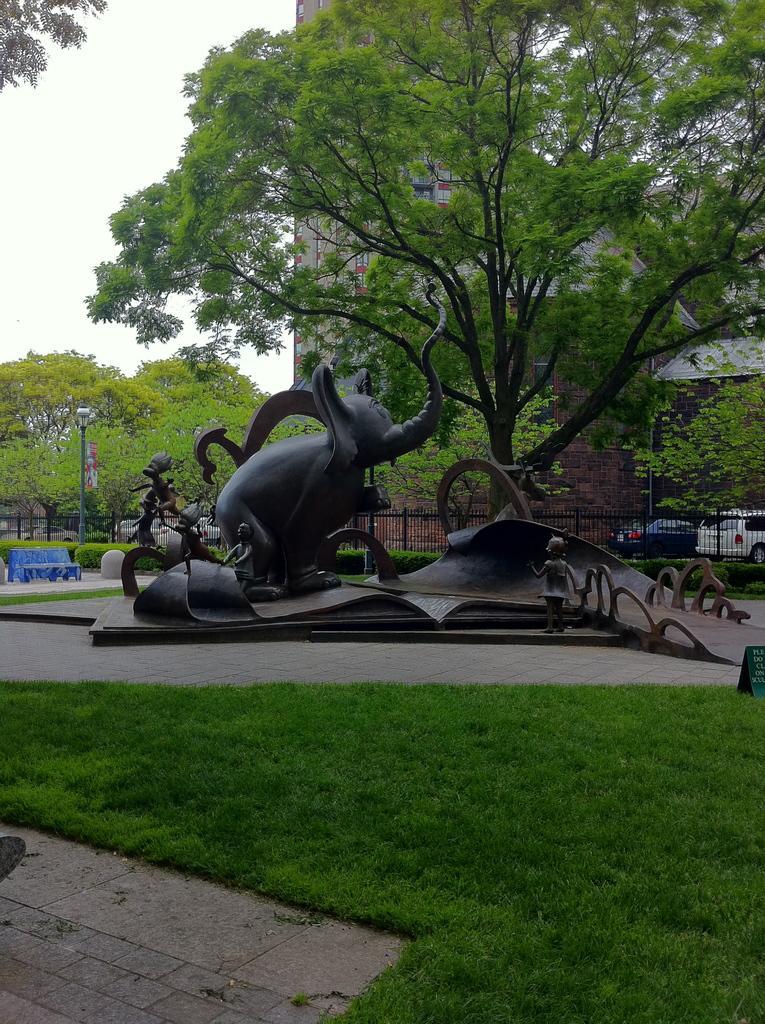In one or two sentences, can you explain what this image depicts? In the center of the image we can see a sculpture. At the bottom there is grass. In the background there is a fence, trees, building, cars and sky. On the left there is a bench. 